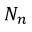<formula> <loc_0><loc_0><loc_500><loc_500>N _ { n }</formula> 